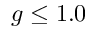Convert formula to latex. <formula><loc_0><loc_0><loc_500><loc_500>g \leq 1 . 0</formula> 